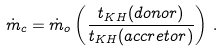Convert formula to latex. <formula><loc_0><loc_0><loc_500><loc_500>\dot { m } _ { c } = \dot { m } _ { o } \left ( \frac { t _ { K H } ( d o n o r ) } { t _ { K H } ( a c c r e t o r ) } \right ) \, .</formula> 